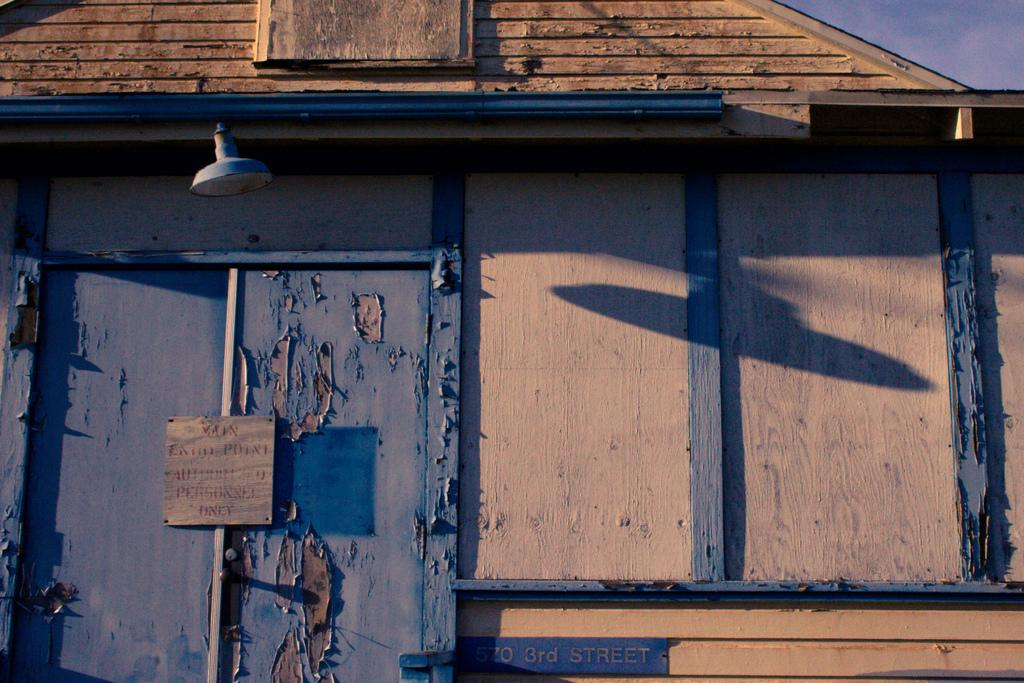What type of structure is present in the image? There is a house in the image. What is attached to the house? Boards are attached to the house. Can you describe the light visible in the image? There is a light visible at the top of the image. How would you describe the color of the sky in the image? The sky is a combination of white and blue colors. What type of statement is being made by the cabbage in the image? There is no cabbage present in the image, so it cannot make any statements. 